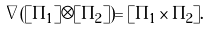<formula> <loc_0><loc_0><loc_500><loc_500>\nabla ( [ \Pi _ { 1 } ] \otimes [ \Pi _ { 2 } ] ) = [ \Pi _ { 1 } \times \Pi _ { 2 } ] .</formula> 